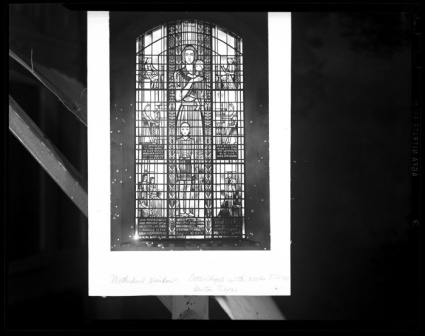Can you tell me about the photography techniques used for capturing images like this one? Photographing stained glass requires consideration of lighting and exposure to capture the rich colors and intricate details. Although this image is in black and white, which does not display the stained glass's vibrant colors, the photographer has adeptly managed the light to avoid glare and ensure that the window's designs are clear. The use of a tripod might have been employed to stabilize the shot, and a narrow aperture to achieve a greater depth of field, making both the window and the surrounding wall distinct. In present times, color photography would be preferable to showcase the glass's hue, but the monochromatic tone here adds an element of timeless grace and emphasizes texture over color. 